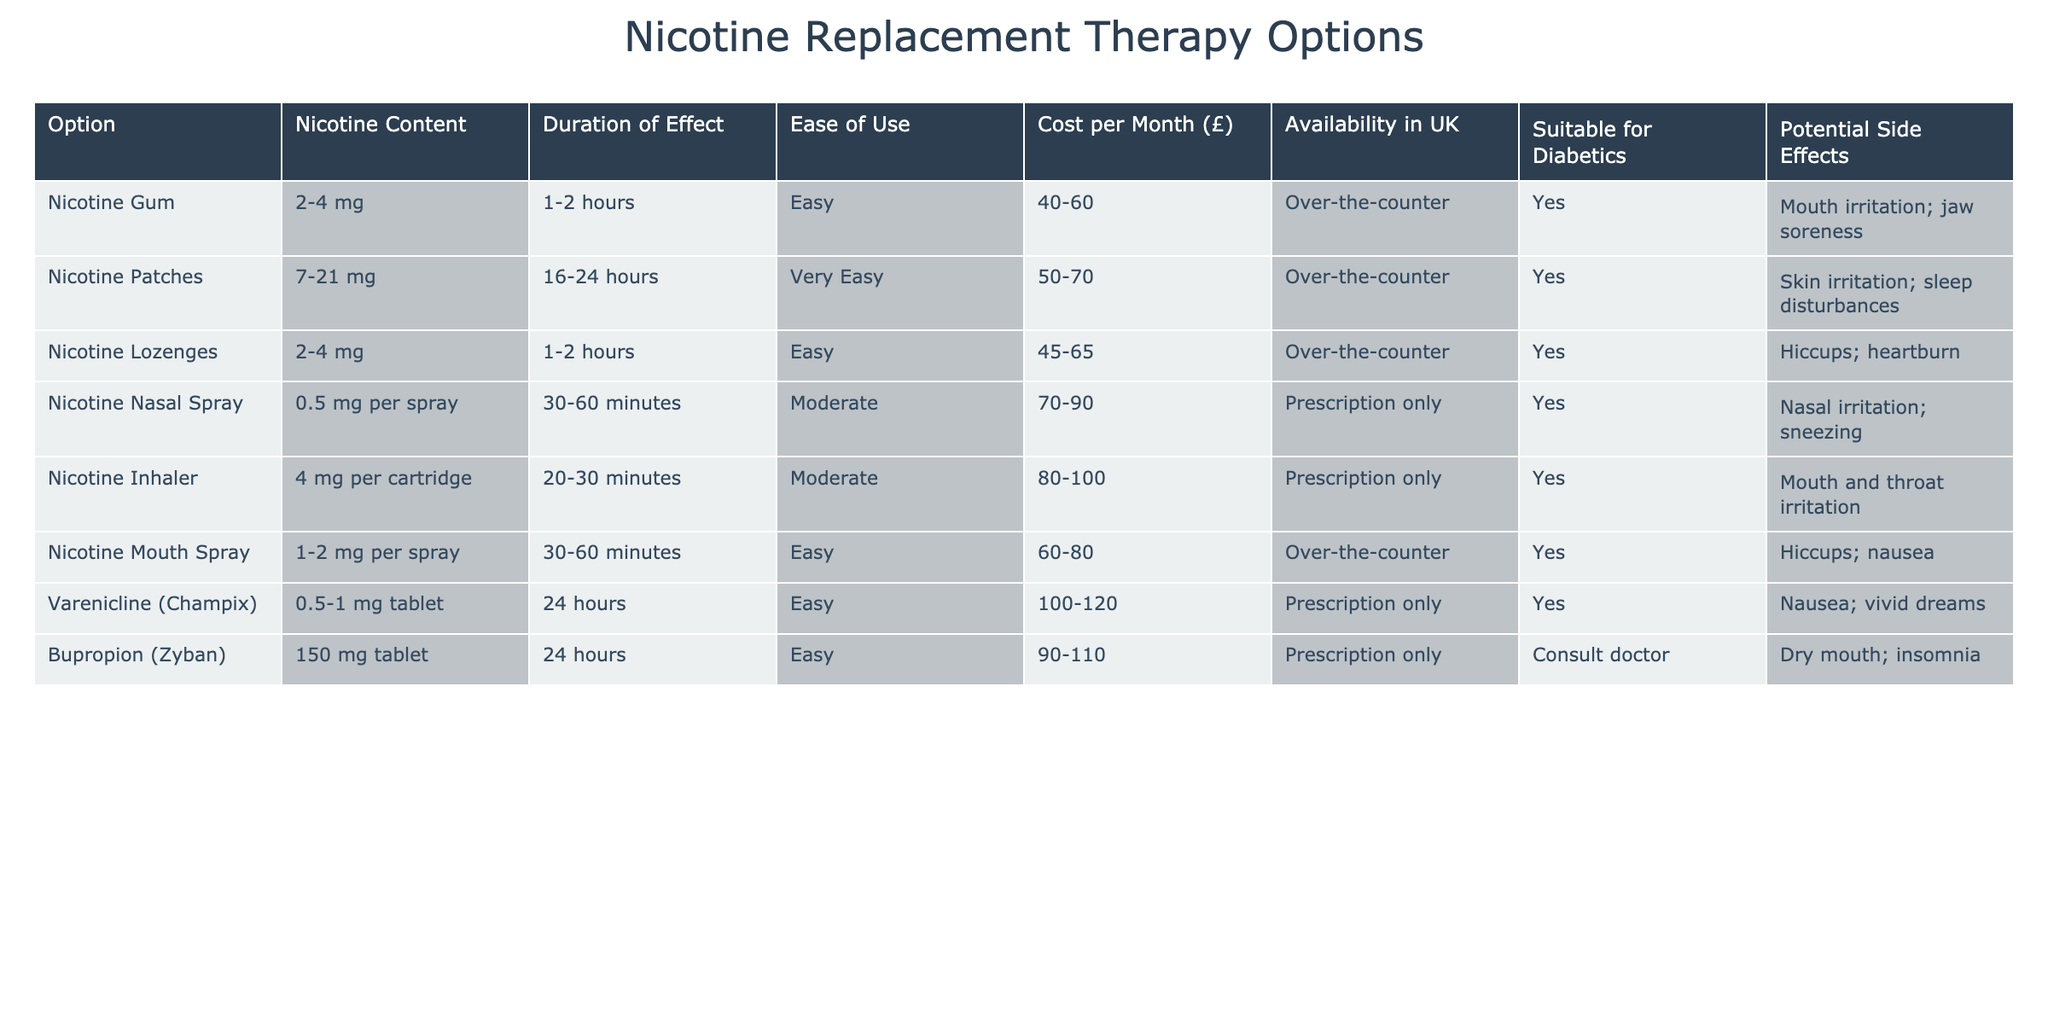What's the nicotine content of Nicotine Gum? The table shows that Nicotine Gum has a nicotine content of 2-4 mg.
Answer: 2-4 mg Which option lasts the longest? By looking at the "Duration of Effect" column, Nicotine Patches stand out with 16-24 hours, which is the longest duration compared to the other options.
Answer: Nicotine Patches Is Nicotine Inhaler suitable for diabetics? The "Suitable for Diabetics" column indicates that the Nicotine Inhaler is marked as "Yes," meaning it is suitable for diabetic users.
Answer: Yes What is the average cost of all options? To find the average cost, we take the range for each option and use a representative value: the midpoints are (50, 60), (60, 70), (55, 65), (80, 90), (90, 100), (70, 80), (110, 120), and (90, 110). The sum of the midpoints is 665, and there are 8 options, so the average cost is 665/8 = 83.13, rounded to two decimal places is 83.12.
Answer: 83.12 Are there any options that might cause skin irritation? The table shows that Nicotine Patches have "Skin irritation" listed as a potential side effect. Therefore, yes, there is an option (Nicotine Patches) that could cause skin irritation.
Answer: Yes Which two options have the highest nicotine content? The options with the highest nicotine content are Nicotine Patches (7-21 mg) and Bupropion (Zyban) (150 mg tablet). Thus, combining these values, we find that Patches have nicotine content averaging 14 mg, while Bupropion's content is straightforwardly 150 mg, leading us to conclude they are the highest.
Answer: Nicotine Patches and Bupropion (Zyban) What side effects are associated with Nicotine Lozenges? According to the table, Nicotine Lozenges have hiccups and heartburn listed as potential side effects.
Answer: Hiccups; heartburn Is there any option with an availability status of "Prescription only"? Looking through the "Availability in UK" column, we can see that Nicotine Nasal Spray, Nicotine Inhaler, Varenicline (Champix), and Bupropion (Zyban) are marked as "Prescription only," confirming that there are options with this status.
Answer: Yes Which option has the easiest ease of use? By examining the "Ease of Use" column, Nicotine Patches are classified as "Very Easy", making them easier to use than the other options in comparison.
Answer: Nicotine Patches 